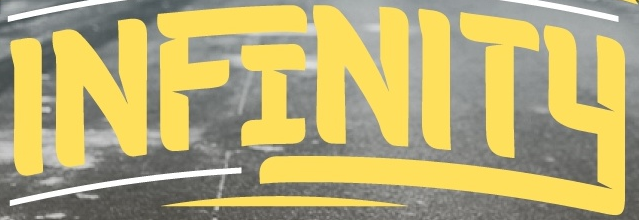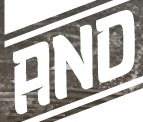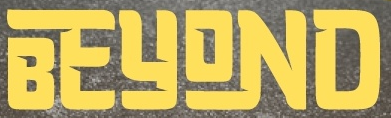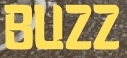Identify the words shown in these images in order, separated by a semicolon. INFINITY; AND; BEYOND; BUZZ 